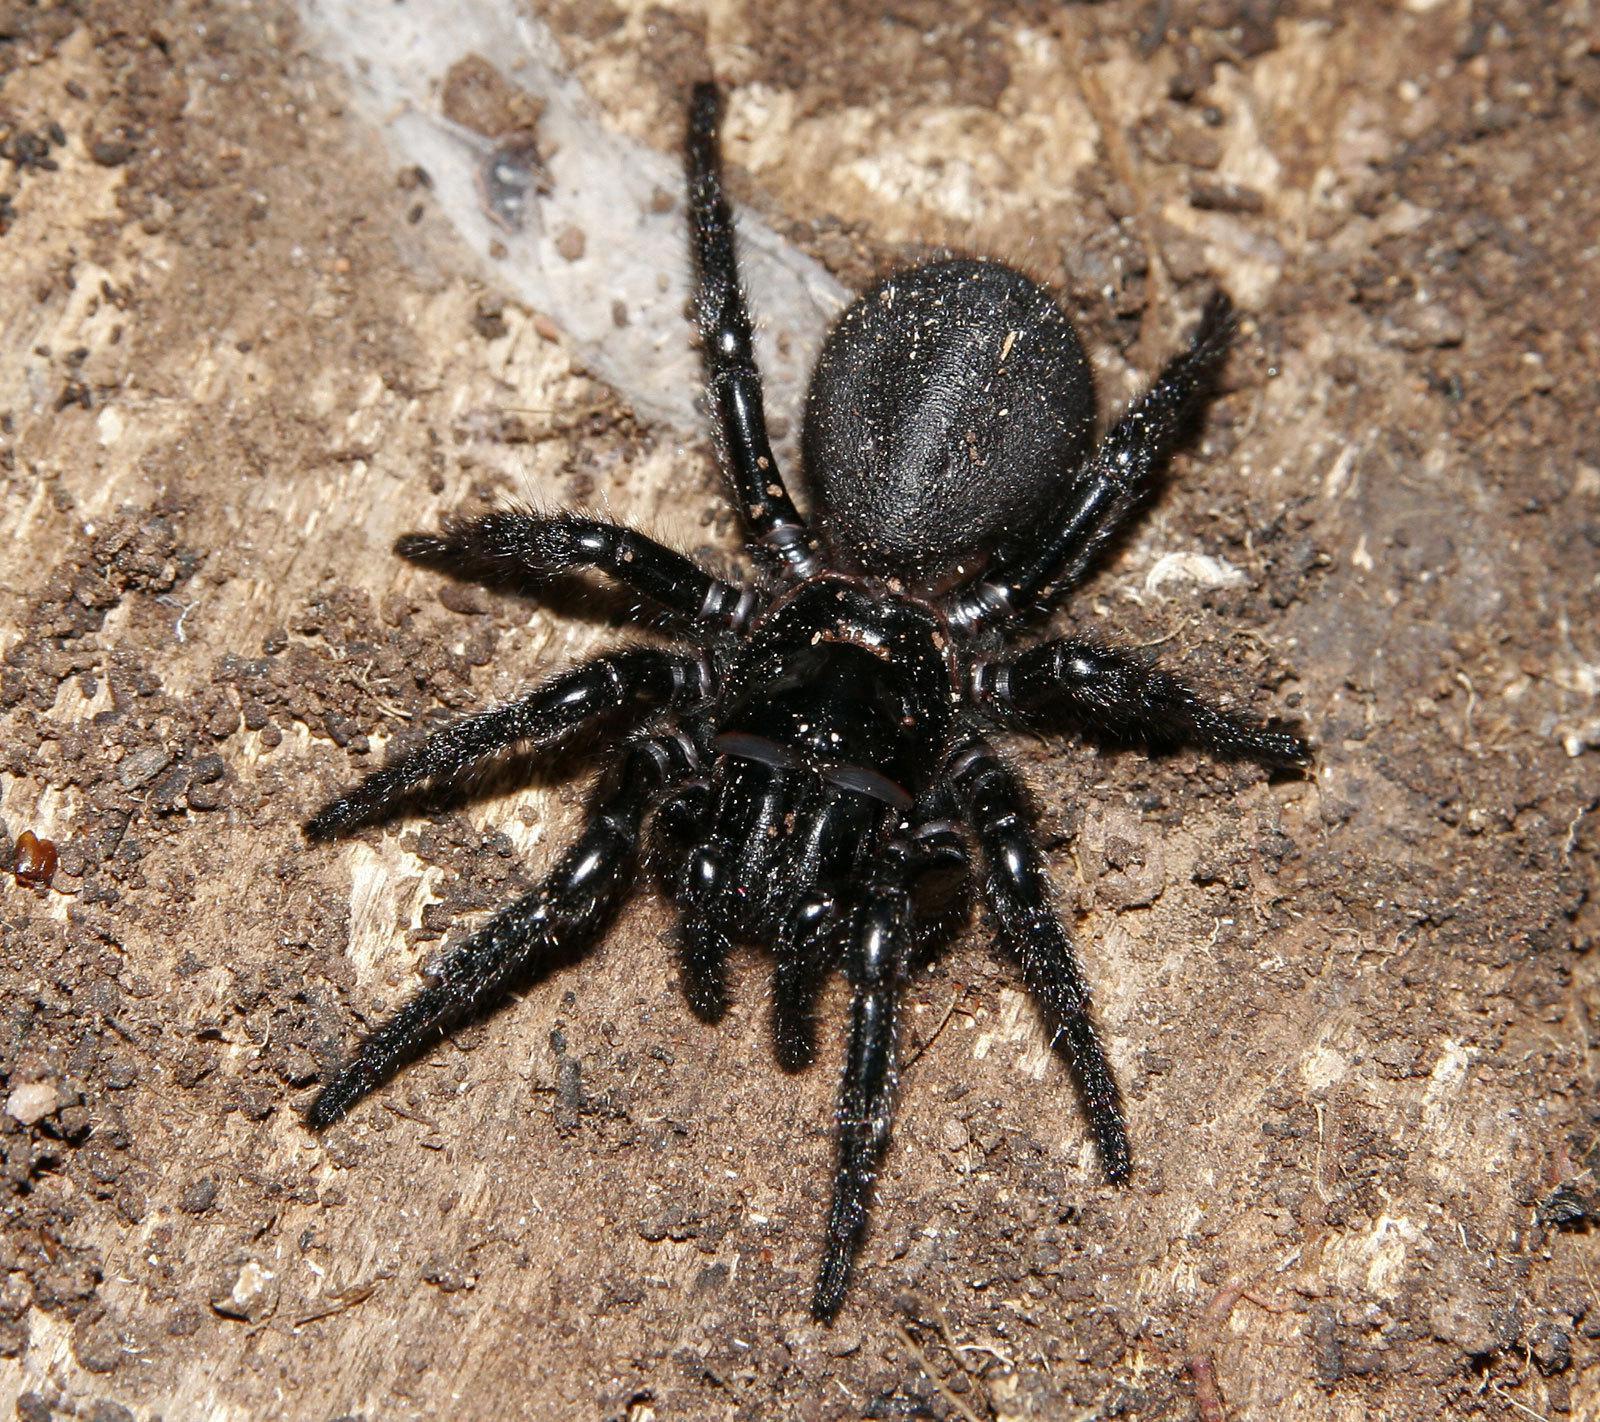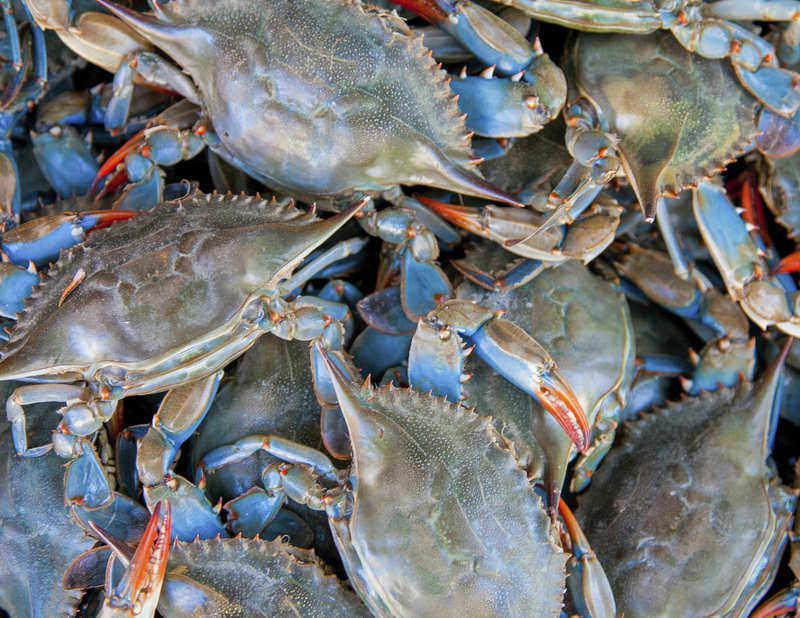The first image is the image on the left, the second image is the image on the right. Assess this claim about the two images: "Eight or fewer crabs are visible.". Correct or not? Answer yes or no. No. The first image is the image on the left, the second image is the image on the right. Analyze the images presented: Is the assertion "The right image contains one animal." valid? Answer yes or no. No. 